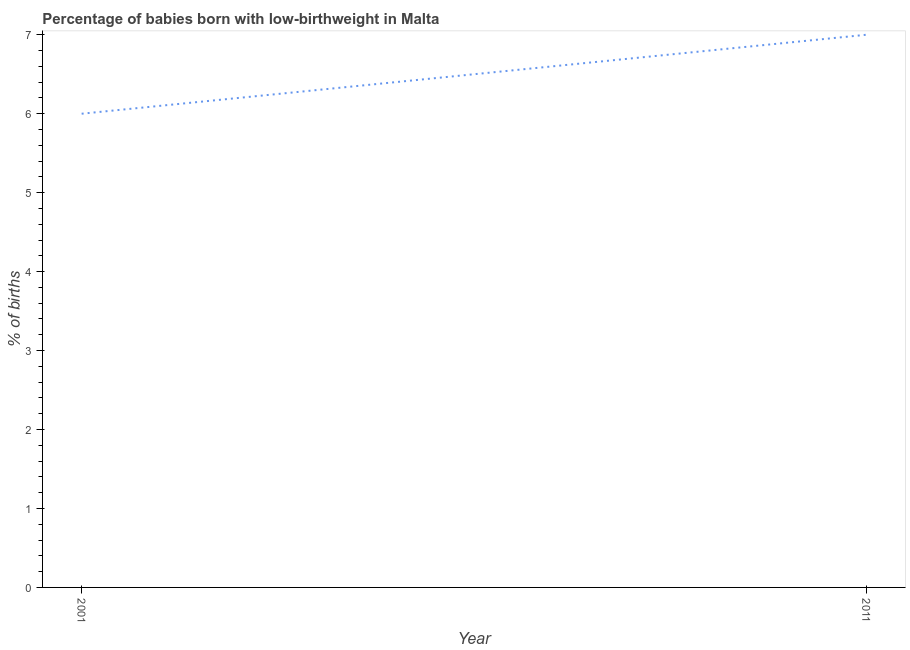What is the percentage of babies who were born with low-birthweight in 2011?
Keep it short and to the point. 7. Across all years, what is the maximum percentage of babies who were born with low-birthweight?
Offer a very short reply. 7. Across all years, what is the minimum percentage of babies who were born with low-birthweight?
Offer a very short reply. 6. What is the sum of the percentage of babies who were born with low-birthweight?
Provide a short and direct response. 13. What is the difference between the percentage of babies who were born with low-birthweight in 2001 and 2011?
Provide a short and direct response. -1. What is the average percentage of babies who were born with low-birthweight per year?
Ensure brevity in your answer.  6.5. In how many years, is the percentage of babies who were born with low-birthweight greater than 4.8 %?
Keep it short and to the point. 2. Do a majority of the years between 2001 and 2011 (inclusive) have percentage of babies who were born with low-birthweight greater than 3.4 %?
Provide a short and direct response. Yes. What is the ratio of the percentage of babies who were born with low-birthweight in 2001 to that in 2011?
Provide a short and direct response. 0.86. Does the percentage of babies who were born with low-birthweight monotonically increase over the years?
Give a very brief answer. Yes. How many years are there in the graph?
Provide a succinct answer. 2. Are the values on the major ticks of Y-axis written in scientific E-notation?
Offer a very short reply. No. Does the graph contain any zero values?
Your response must be concise. No. What is the title of the graph?
Keep it short and to the point. Percentage of babies born with low-birthweight in Malta. What is the label or title of the Y-axis?
Your answer should be very brief. % of births. What is the % of births in 2001?
Make the answer very short. 6. What is the % of births in 2011?
Provide a succinct answer. 7. What is the ratio of the % of births in 2001 to that in 2011?
Provide a short and direct response. 0.86. 